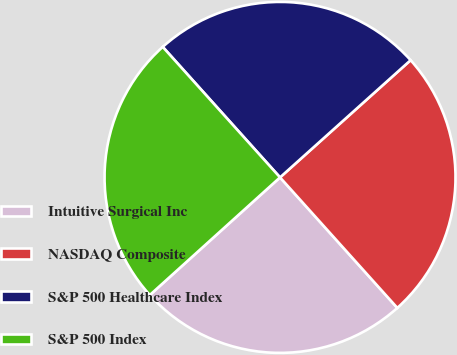<chart> <loc_0><loc_0><loc_500><loc_500><pie_chart><fcel>Intuitive Surgical Inc<fcel>NASDAQ Composite<fcel>S&P 500 Healthcare Index<fcel>S&P 500 Index<nl><fcel>24.96%<fcel>24.99%<fcel>25.01%<fcel>25.04%<nl></chart> 